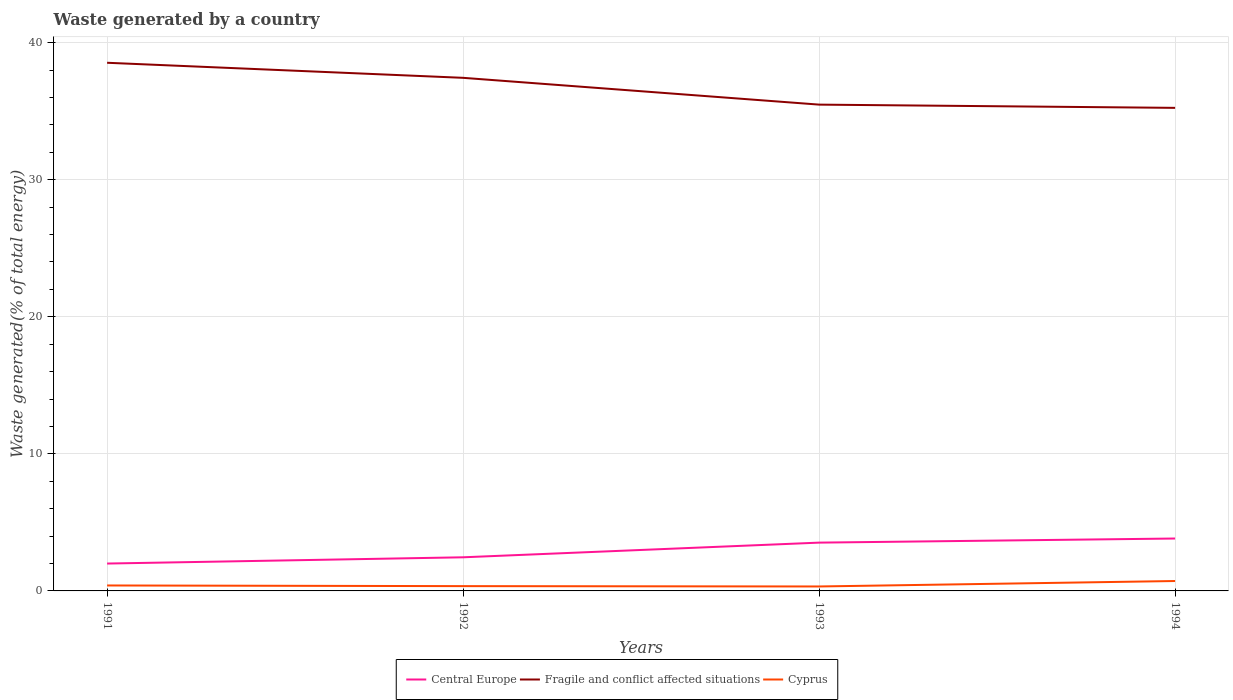Is the number of lines equal to the number of legend labels?
Your answer should be compact. Yes. Across all years, what is the maximum total waste generated in Central Europe?
Make the answer very short. 2. What is the total total waste generated in Cyprus in the graph?
Keep it short and to the point. -0.37. What is the difference between the highest and the second highest total waste generated in Cyprus?
Your response must be concise. 0.4. How many years are there in the graph?
Give a very brief answer. 4. What is the difference between two consecutive major ticks on the Y-axis?
Keep it short and to the point. 10. Where does the legend appear in the graph?
Keep it short and to the point. Bottom center. How are the legend labels stacked?
Make the answer very short. Horizontal. What is the title of the graph?
Give a very brief answer. Waste generated by a country. Does "Korea (Republic)" appear as one of the legend labels in the graph?
Keep it short and to the point. No. What is the label or title of the X-axis?
Give a very brief answer. Years. What is the label or title of the Y-axis?
Your response must be concise. Waste generated(% of total energy). What is the Waste generated(% of total energy) in Central Europe in 1991?
Offer a terse response. 2. What is the Waste generated(% of total energy) in Fragile and conflict affected situations in 1991?
Provide a succinct answer. 38.53. What is the Waste generated(% of total energy) of Cyprus in 1991?
Provide a short and direct response. 0.4. What is the Waste generated(% of total energy) of Central Europe in 1992?
Your answer should be very brief. 2.45. What is the Waste generated(% of total energy) in Fragile and conflict affected situations in 1992?
Make the answer very short. 37.43. What is the Waste generated(% of total energy) of Cyprus in 1992?
Provide a succinct answer. 0.35. What is the Waste generated(% of total energy) in Central Europe in 1993?
Your answer should be compact. 3.52. What is the Waste generated(% of total energy) of Fragile and conflict affected situations in 1993?
Provide a succinct answer. 35.48. What is the Waste generated(% of total energy) of Cyprus in 1993?
Your response must be concise. 0.32. What is the Waste generated(% of total energy) of Central Europe in 1994?
Your response must be concise. 3.82. What is the Waste generated(% of total energy) of Fragile and conflict affected situations in 1994?
Offer a terse response. 35.24. What is the Waste generated(% of total energy) in Cyprus in 1994?
Provide a short and direct response. 0.72. Across all years, what is the maximum Waste generated(% of total energy) in Central Europe?
Offer a terse response. 3.82. Across all years, what is the maximum Waste generated(% of total energy) of Fragile and conflict affected situations?
Provide a succinct answer. 38.53. Across all years, what is the maximum Waste generated(% of total energy) of Cyprus?
Offer a terse response. 0.72. Across all years, what is the minimum Waste generated(% of total energy) in Central Europe?
Offer a very short reply. 2. Across all years, what is the minimum Waste generated(% of total energy) of Fragile and conflict affected situations?
Your answer should be compact. 35.24. Across all years, what is the minimum Waste generated(% of total energy) in Cyprus?
Make the answer very short. 0.32. What is the total Waste generated(% of total energy) of Central Europe in the graph?
Your response must be concise. 11.8. What is the total Waste generated(% of total energy) of Fragile and conflict affected situations in the graph?
Offer a terse response. 146.69. What is the total Waste generated(% of total energy) in Cyprus in the graph?
Your answer should be compact. 1.8. What is the difference between the Waste generated(% of total energy) of Central Europe in 1991 and that in 1992?
Your response must be concise. -0.46. What is the difference between the Waste generated(% of total energy) of Fragile and conflict affected situations in 1991 and that in 1992?
Your answer should be very brief. 1.1. What is the difference between the Waste generated(% of total energy) of Cyprus in 1991 and that in 1992?
Make the answer very short. 0.05. What is the difference between the Waste generated(% of total energy) in Central Europe in 1991 and that in 1993?
Offer a very short reply. -1.53. What is the difference between the Waste generated(% of total energy) of Fragile and conflict affected situations in 1991 and that in 1993?
Make the answer very short. 3.05. What is the difference between the Waste generated(% of total energy) in Cyprus in 1991 and that in 1993?
Provide a succinct answer. 0.07. What is the difference between the Waste generated(% of total energy) in Central Europe in 1991 and that in 1994?
Provide a short and direct response. -1.83. What is the difference between the Waste generated(% of total energy) of Fragile and conflict affected situations in 1991 and that in 1994?
Offer a terse response. 3.29. What is the difference between the Waste generated(% of total energy) of Cyprus in 1991 and that in 1994?
Your response must be concise. -0.33. What is the difference between the Waste generated(% of total energy) in Central Europe in 1992 and that in 1993?
Keep it short and to the point. -1.07. What is the difference between the Waste generated(% of total energy) of Fragile and conflict affected situations in 1992 and that in 1993?
Provide a short and direct response. 1.95. What is the difference between the Waste generated(% of total energy) in Cyprus in 1992 and that in 1993?
Ensure brevity in your answer.  0.03. What is the difference between the Waste generated(% of total energy) in Central Europe in 1992 and that in 1994?
Provide a short and direct response. -1.37. What is the difference between the Waste generated(% of total energy) of Fragile and conflict affected situations in 1992 and that in 1994?
Ensure brevity in your answer.  2.19. What is the difference between the Waste generated(% of total energy) in Cyprus in 1992 and that in 1994?
Provide a succinct answer. -0.37. What is the difference between the Waste generated(% of total energy) of Central Europe in 1993 and that in 1994?
Keep it short and to the point. -0.3. What is the difference between the Waste generated(% of total energy) of Fragile and conflict affected situations in 1993 and that in 1994?
Provide a succinct answer. 0.24. What is the difference between the Waste generated(% of total energy) of Cyprus in 1993 and that in 1994?
Provide a short and direct response. -0.4. What is the difference between the Waste generated(% of total energy) of Central Europe in 1991 and the Waste generated(% of total energy) of Fragile and conflict affected situations in 1992?
Make the answer very short. -35.44. What is the difference between the Waste generated(% of total energy) in Central Europe in 1991 and the Waste generated(% of total energy) in Cyprus in 1992?
Offer a very short reply. 1.65. What is the difference between the Waste generated(% of total energy) in Fragile and conflict affected situations in 1991 and the Waste generated(% of total energy) in Cyprus in 1992?
Make the answer very short. 38.18. What is the difference between the Waste generated(% of total energy) of Central Europe in 1991 and the Waste generated(% of total energy) of Fragile and conflict affected situations in 1993?
Offer a very short reply. -33.48. What is the difference between the Waste generated(% of total energy) of Central Europe in 1991 and the Waste generated(% of total energy) of Cyprus in 1993?
Your answer should be very brief. 1.67. What is the difference between the Waste generated(% of total energy) of Fragile and conflict affected situations in 1991 and the Waste generated(% of total energy) of Cyprus in 1993?
Offer a very short reply. 38.21. What is the difference between the Waste generated(% of total energy) of Central Europe in 1991 and the Waste generated(% of total energy) of Fragile and conflict affected situations in 1994?
Give a very brief answer. -33.24. What is the difference between the Waste generated(% of total energy) of Central Europe in 1991 and the Waste generated(% of total energy) of Cyprus in 1994?
Your answer should be very brief. 1.27. What is the difference between the Waste generated(% of total energy) of Fragile and conflict affected situations in 1991 and the Waste generated(% of total energy) of Cyprus in 1994?
Offer a terse response. 37.81. What is the difference between the Waste generated(% of total energy) of Central Europe in 1992 and the Waste generated(% of total energy) of Fragile and conflict affected situations in 1993?
Provide a short and direct response. -33.03. What is the difference between the Waste generated(% of total energy) in Central Europe in 1992 and the Waste generated(% of total energy) in Cyprus in 1993?
Give a very brief answer. 2.13. What is the difference between the Waste generated(% of total energy) of Fragile and conflict affected situations in 1992 and the Waste generated(% of total energy) of Cyprus in 1993?
Provide a short and direct response. 37.11. What is the difference between the Waste generated(% of total energy) in Central Europe in 1992 and the Waste generated(% of total energy) in Fragile and conflict affected situations in 1994?
Your response must be concise. -32.79. What is the difference between the Waste generated(% of total energy) of Central Europe in 1992 and the Waste generated(% of total energy) of Cyprus in 1994?
Ensure brevity in your answer.  1.73. What is the difference between the Waste generated(% of total energy) of Fragile and conflict affected situations in 1992 and the Waste generated(% of total energy) of Cyprus in 1994?
Provide a succinct answer. 36.71. What is the difference between the Waste generated(% of total energy) of Central Europe in 1993 and the Waste generated(% of total energy) of Fragile and conflict affected situations in 1994?
Offer a very short reply. -31.72. What is the difference between the Waste generated(% of total energy) of Central Europe in 1993 and the Waste generated(% of total energy) of Cyprus in 1994?
Provide a short and direct response. 2.8. What is the difference between the Waste generated(% of total energy) in Fragile and conflict affected situations in 1993 and the Waste generated(% of total energy) in Cyprus in 1994?
Offer a very short reply. 34.76. What is the average Waste generated(% of total energy) of Central Europe per year?
Ensure brevity in your answer.  2.95. What is the average Waste generated(% of total energy) of Fragile and conflict affected situations per year?
Your answer should be compact. 36.67. What is the average Waste generated(% of total energy) in Cyprus per year?
Give a very brief answer. 0.45. In the year 1991, what is the difference between the Waste generated(% of total energy) in Central Europe and Waste generated(% of total energy) in Fragile and conflict affected situations?
Make the answer very short. -36.54. In the year 1991, what is the difference between the Waste generated(% of total energy) of Central Europe and Waste generated(% of total energy) of Cyprus?
Offer a terse response. 1.6. In the year 1991, what is the difference between the Waste generated(% of total energy) in Fragile and conflict affected situations and Waste generated(% of total energy) in Cyprus?
Provide a succinct answer. 38.13. In the year 1992, what is the difference between the Waste generated(% of total energy) in Central Europe and Waste generated(% of total energy) in Fragile and conflict affected situations?
Provide a short and direct response. -34.98. In the year 1992, what is the difference between the Waste generated(% of total energy) of Central Europe and Waste generated(% of total energy) of Cyprus?
Offer a terse response. 2.1. In the year 1992, what is the difference between the Waste generated(% of total energy) in Fragile and conflict affected situations and Waste generated(% of total energy) in Cyprus?
Provide a short and direct response. 37.08. In the year 1993, what is the difference between the Waste generated(% of total energy) in Central Europe and Waste generated(% of total energy) in Fragile and conflict affected situations?
Ensure brevity in your answer.  -31.96. In the year 1993, what is the difference between the Waste generated(% of total energy) of Central Europe and Waste generated(% of total energy) of Cyprus?
Offer a terse response. 3.2. In the year 1993, what is the difference between the Waste generated(% of total energy) of Fragile and conflict affected situations and Waste generated(% of total energy) of Cyprus?
Ensure brevity in your answer.  35.15. In the year 1994, what is the difference between the Waste generated(% of total energy) of Central Europe and Waste generated(% of total energy) of Fragile and conflict affected situations?
Provide a succinct answer. -31.42. In the year 1994, what is the difference between the Waste generated(% of total energy) of Central Europe and Waste generated(% of total energy) of Cyprus?
Ensure brevity in your answer.  3.1. In the year 1994, what is the difference between the Waste generated(% of total energy) of Fragile and conflict affected situations and Waste generated(% of total energy) of Cyprus?
Offer a very short reply. 34.52. What is the ratio of the Waste generated(% of total energy) in Central Europe in 1991 to that in 1992?
Provide a short and direct response. 0.81. What is the ratio of the Waste generated(% of total energy) in Fragile and conflict affected situations in 1991 to that in 1992?
Your response must be concise. 1.03. What is the ratio of the Waste generated(% of total energy) of Cyprus in 1991 to that in 1992?
Offer a terse response. 1.14. What is the ratio of the Waste generated(% of total energy) in Central Europe in 1991 to that in 1993?
Your answer should be very brief. 0.57. What is the ratio of the Waste generated(% of total energy) of Fragile and conflict affected situations in 1991 to that in 1993?
Your answer should be compact. 1.09. What is the ratio of the Waste generated(% of total energy) of Cyprus in 1991 to that in 1993?
Make the answer very short. 1.22. What is the ratio of the Waste generated(% of total energy) in Central Europe in 1991 to that in 1994?
Ensure brevity in your answer.  0.52. What is the ratio of the Waste generated(% of total energy) in Fragile and conflict affected situations in 1991 to that in 1994?
Make the answer very short. 1.09. What is the ratio of the Waste generated(% of total energy) of Cyprus in 1991 to that in 1994?
Offer a very short reply. 0.55. What is the ratio of the Waste generated(% of total energy) in Central Europe in 1992 to that in 1993?
Your answer should be compact. 0.7. What is the ratio of the Waste generated(% of total energy) in Fragile and conflict affected situations in 1992 to that in 1993?
Offer a very short reply. 1.06. What is the ratio of the Waste generated(% of total energy) in Cyprus in 1992 to that in 1993?
Keep it short and to the point. 1.08. What is the ratio of the Waste generated(% of total energy) of Central Europe in 1992 to that in 1994?
Provide a succinct answer. 0.64. What is the ratio of the Waste generated(% of total energy) in Fragile and conflict affected situations in 1992 to that in 1994?
Provide a short and direct response. 1.06. What is the ratio of the Waste generated(% of total energy) of Cyprus in 1992 to that in 1994?
Your response must be concise. 0.48. What is the ratio of the Waste generated(% of total energy) of Central Europe in 1993 to that in 1994?
Give a very brief answer. 0.92. What is the ratio of the Waste generated(% of total energy) of Fragile and conflict affected situations in 1993 to that in 1994?
Your answer should be very brief. 1.01. What is the ratio of the Waste generated(% of total energy) in Cyprus in 1993 to that in 1994?
Offer a terse response. 0.45. What is the difference between the highest and the second highest Waste generated(% of total energy) in Central Europe?
Make the answer very short. 0.3. What is the difference between the highest and the second highest Waste generated(% of total energy) of Fragile and conflict affected situations?
Your answer should be compact. 1.1. What is the difference between the highest and the second highest Waste generated(% of total energy) of Cyprus?
Your answer should be compact. 0.33. What is the difference between the highest and the lowest Waste generated(% of total energy) of Central Europe?
Your answer should be very brief. 1.83. What is the difference between the highest and the lowest Waste generated(% of total energy) in Fragile and conflict affected situations?
Your answer should be very brief. 3.29. What is the difference between the highest and the lowest Waste generated(% of total energy) in Cyprus?
Give a very brief answer. 0.4. 